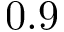Convert formula to latex. <formula><loc_0><loc_0><loc_500><loc_500>0 . 9</formula> 